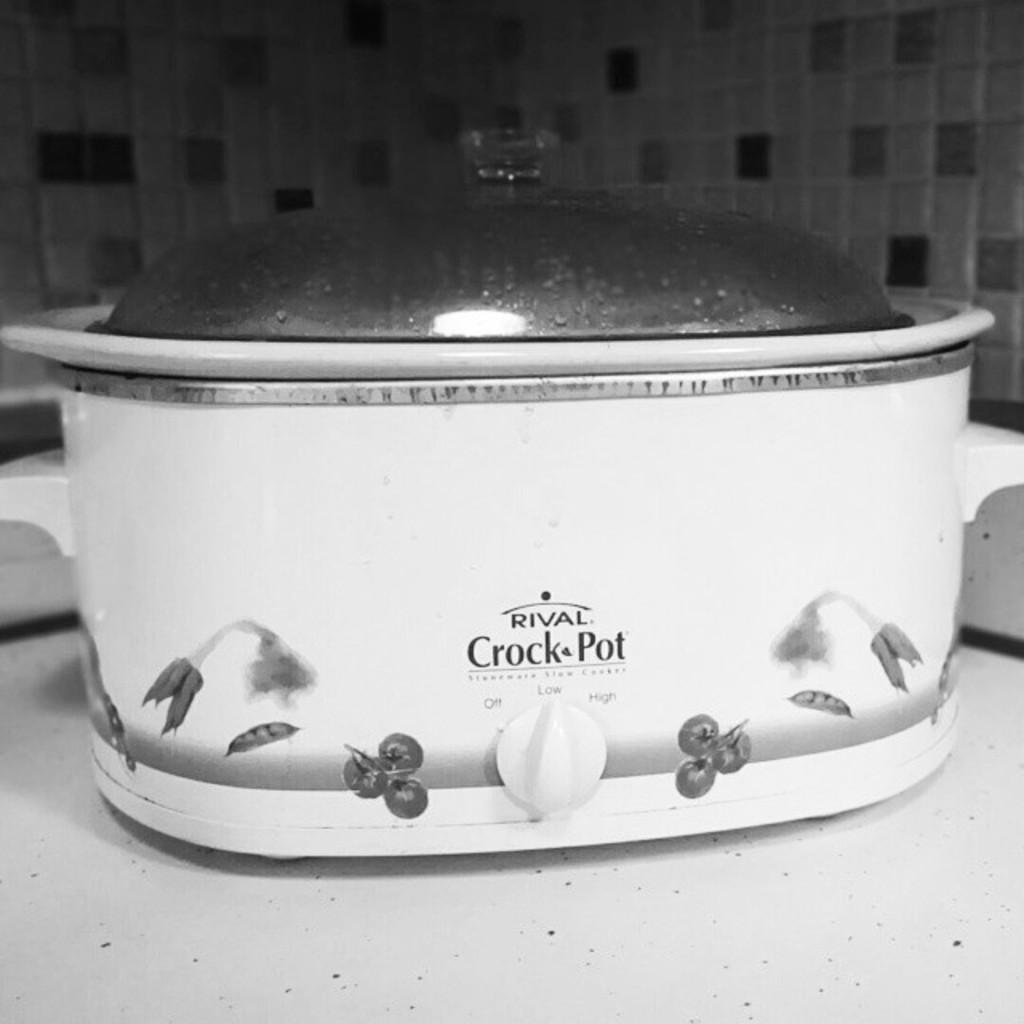<image>
Provide a brief description of the given image. A crock pot which has the name Rival on it. 